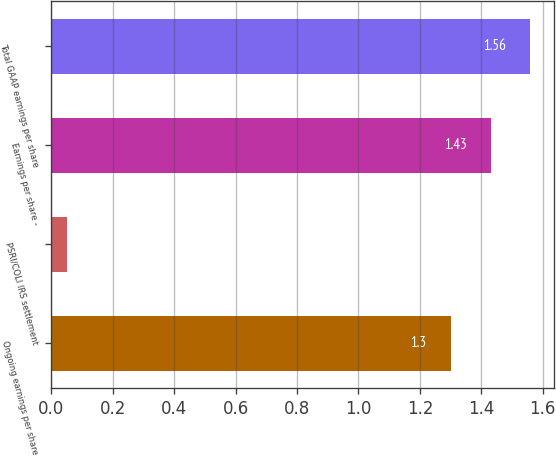<chart> <loc_0><loc_0><loc_500><loc_500><bar_chart><fcel>Ongoing earnings per share<fcel>PSRI/COLI IRS settlement<fcel>Earnings per share -<fcel>Total GAAP earnings per share<nl><fcel>1.3<fcel>0.05<fcel>1.43<fcel>1.56<nl></chart> 